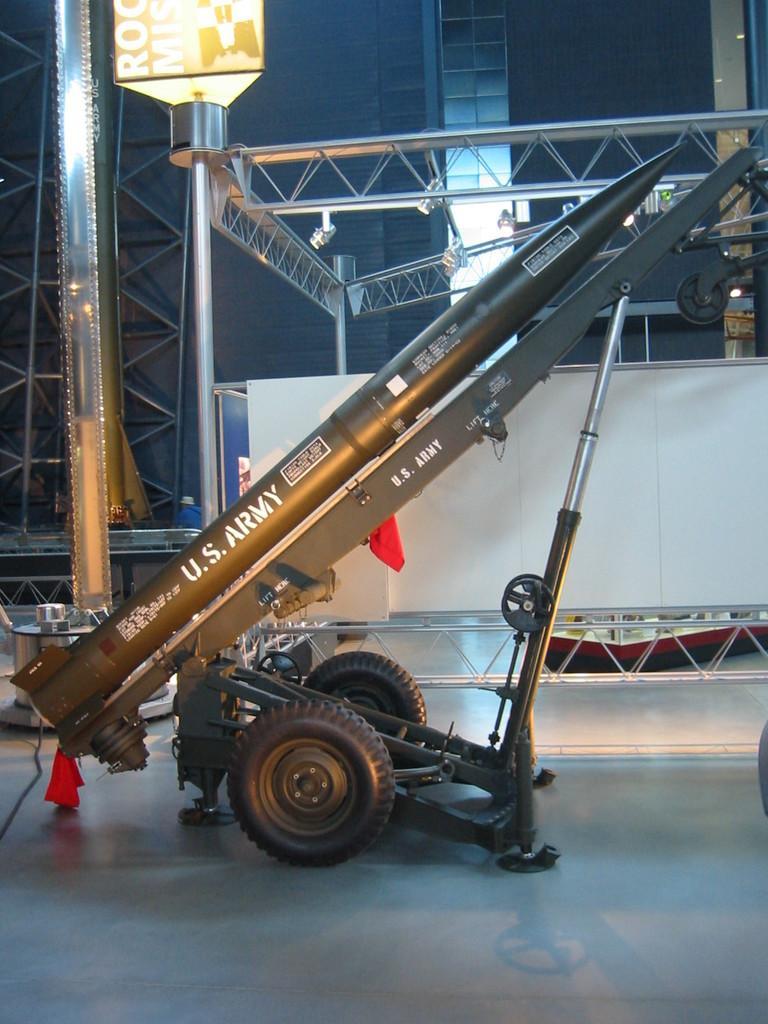How would you summarize this image in a sentence or two? In this picture there is a missile in the center of the image and there is a pole on the left side of the image and there is a boundary and a building in the background area of the image and there is a lamp at the top side of the image. 